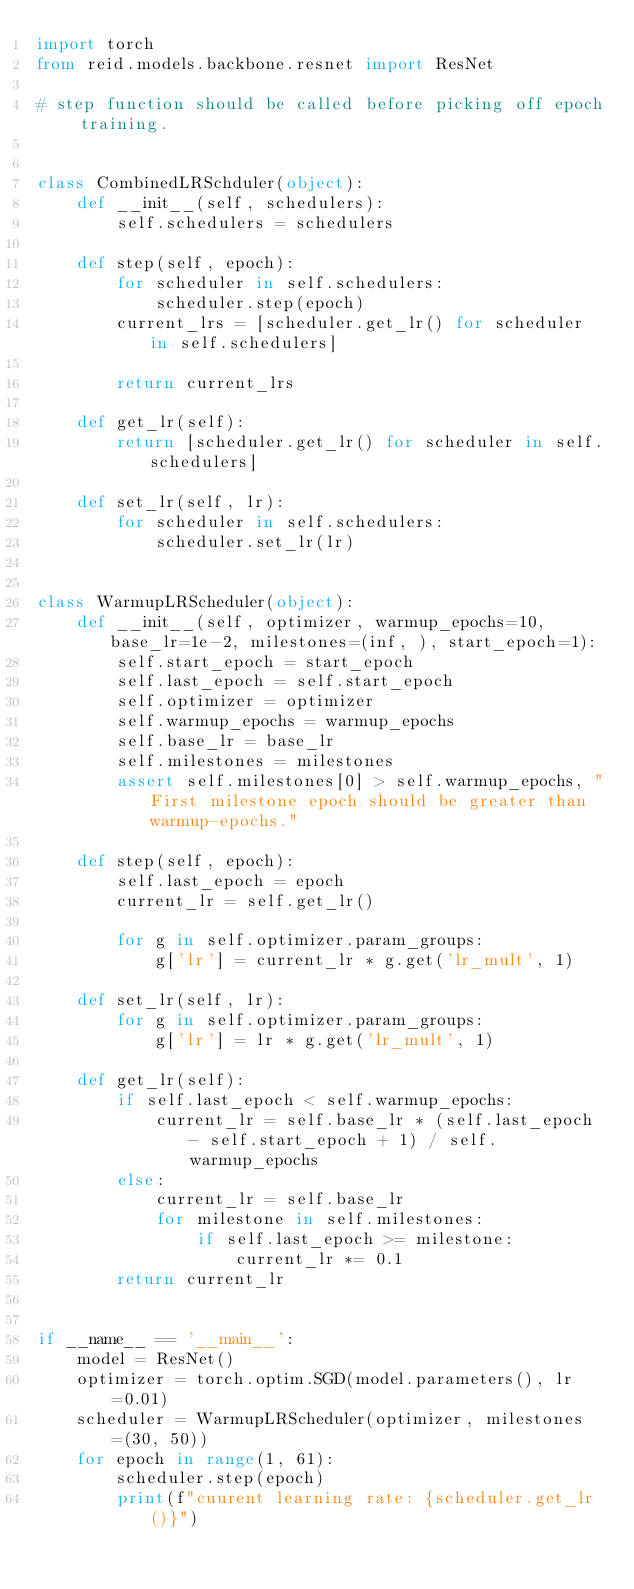<code> <loc_0><loc_0><loc_500><loc_500><_Python_>import torch
from reid.models.backbone.resnet import ResNet

# step function should be called before picking off epoch training.


class CombinedLRSchduler(object):
    def __init__(self, schedulers):
        self.schedulers = schedulers

    def step(self, epoch):
        for scheduler in self.schedulers:
            scheduler.step(epoch)
        current_lrs = [scheduler.get_lr() for scheduler in self.schedulers]

        return current_lrs

    def get_lr(self):
        return [scheduler.get_lr() for scheduler in self.schedulers]

    def set_lr(self, lr):
        for scheduler in self.schedulers:
            scheduler.set_lr(lr)


class WarmupLRScheduler(object):
    def __init__(self, optimizer, warmup_epochs=10, base_lr=1e-2, milestones=(inf, ), start_epoch=1):
        self.start_epoch = start_epoch
        self.last_epoch = self.start_epoch
        self.optimizer = optimizer
        self.warmup_epochs = warmup_epochs
        self.base_lr = base_lr
        self.milestones = milestones
        assert self.milestones[0] > self.warmup_epochs, "First milestone epoch should be greater than warmup-epochs."

    def step(self, epoch):
        self.last_epoch = epoch
        current_lr = self.get_lr()

        for g in self.optimizer.param_groups:
            g['lr'] = current_lr * g.get('lr_mult', 1)

    def set_lr(self, lr):
        for g in self.optimizer.param_groups:
            g['lr'] = lr * g.get('lr_mult', 1)

    def get_lr(self):
        if self.last_epoch < self.warmup_epochs:
            current_lr = self.base_lr * (self.last_epoch - self.start_epoch + 1) / self.warmup_epochs
        else:
            current_lr = self.base_lr
            for milestone in self.milestones:
                if self.last_epoch >= milestone:
                    current_lr *= 0.1
        return current_lr


if __name__ == '__main__':
    model = ResNet()
    optimizer = torch.optim.SGD(model.parameters(), lr=0.01)
    scheduler = WarmupLRScheduler(optimizer, milestones=(30, 50))
    for epoch in range(1, 61):
        scheduler.step(epoch)
        print(f"cuurent learning rate: {scheduler.get_lr()}")
</code> 